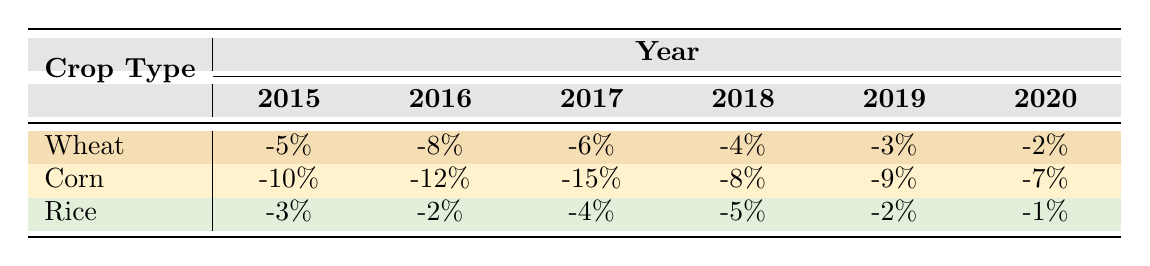What was the Yield Impact Percentage for Corn in 2017? According to the table, the Yield Impact Percentage for Corn in 2017 is -15%.
Answer: -15% Which crop had the least negative impact on yield in 2019? From the table, the Yield Impact Percentages in 2019 are -3% for Wheat, -9% for Corn, and -2% for Rice. Comparing these values, Rice has the least negative impact at -2%.
Answer: Rice What is the average Yield Impact Percentage for Wheat from 2015 to 2020? The Yield Impact Percentages for Wheat from 2015 to 2020 are -5%, -8%, -6%, -4%, -3%, and -2%. Adding these up gives: -5 + (-8) + (-6) + (-4) + (-3) + (-2) = -28%. Dividing by the number of years (6) results in an average of -28% / 6 = -4.67%.
Answer: -4.67% Did Rice have a more positive impact than Wheat in 2018? In 2018, Rice had a Yield Impact Percentage of -5% while Wheat had -4%. Since -5% is more negative than -4%, Rice did not have a more positive impact than Wheat.
Answer: No What was the total Yield Impact Percentage for Corn from 2015 to 2020? The Yield Impact Percentages for Corn from 2015 to 2020 are -10%, -12%, -15%, -8%, -9%, and -7%. Summing these values gives: -10 + (-12) + (-15) + (-8) + (-9) + (-7) = -61%.
Answer: -61% 